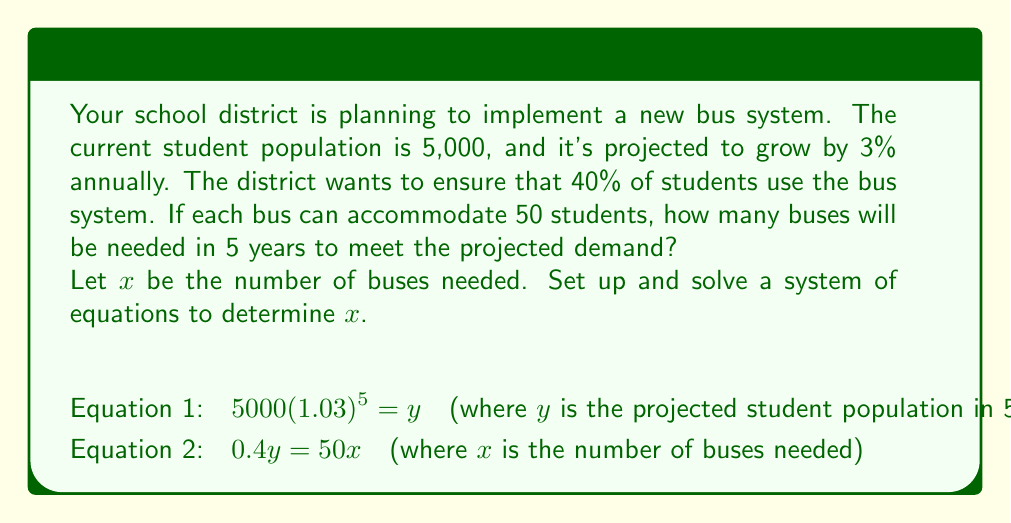What is the answer to this math problem? Let's solve this problem step by step:

1. First, we need to calculate the projected student population in 5 years:
   $y = 5000(1.03)^5$
   $y = 5000 * 1.159274$
   $y = 5796.37$ (rounded to 2 decimal places)

2. Now that we have $y$, we can set up the second equation:
   $0.4y = 50x$

3. Substitute the value of $y$:
   $0.4(5796.37) = 50x$

4. Simplify:
   $2318.548 = 50x$

5. Solve for $x$:
   $x = 2318.548 / 50$
   $x = 46.37096$

6. Since we can't have a fraction of a bus, we need to round up to the nearest whole number:
   $x = 47$

Therefore, the school district will need 47 buses in 5 years to meet the projected demand.
Answer: 47 buses 